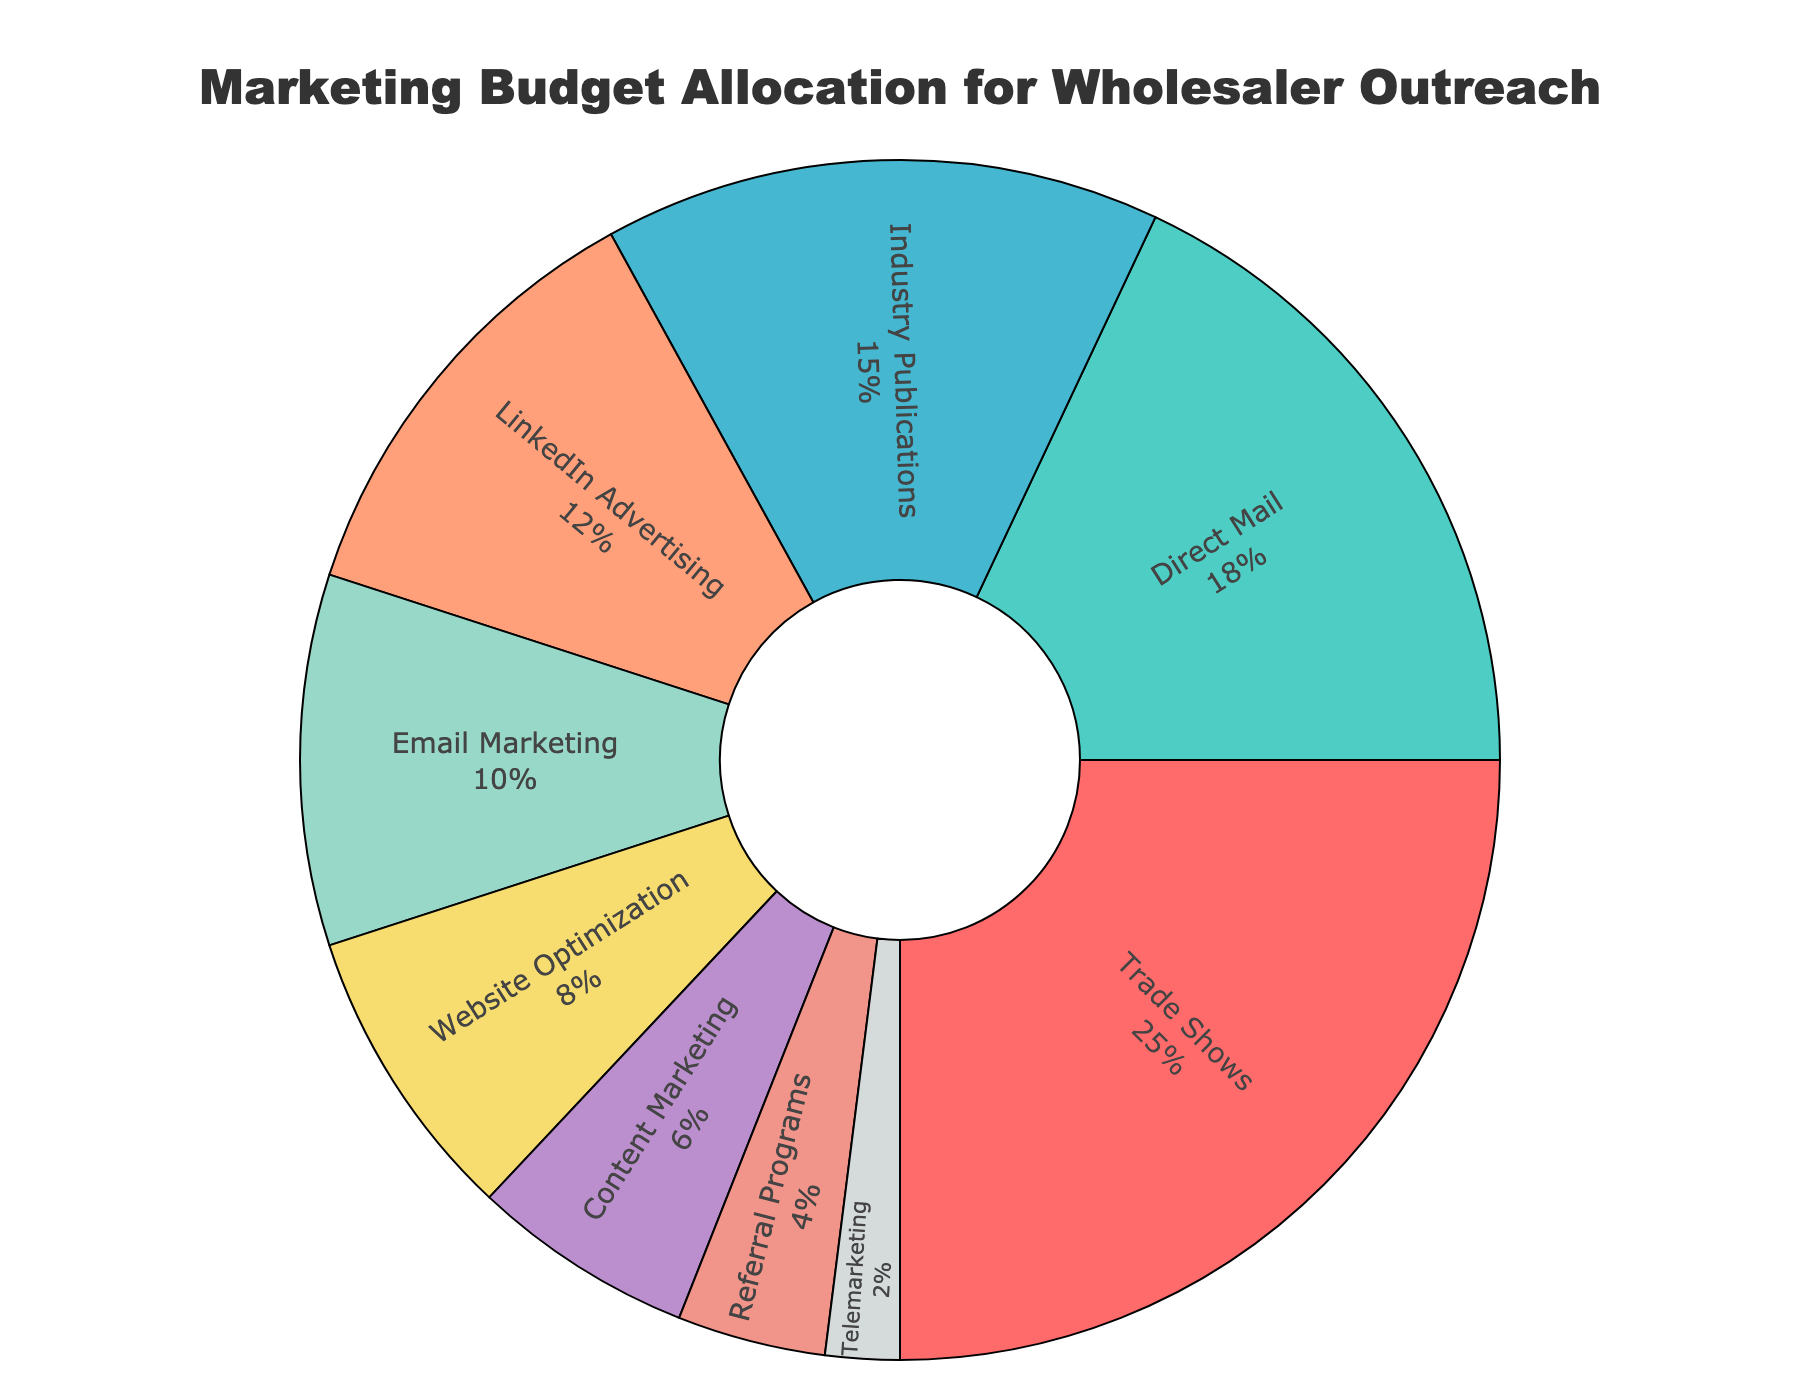Which channel has the highest marketing budget allocation? The channel with the highest marketing budget allocation is shown as the largest slice in the pie chart.
Answer: Trade Shows What is the combined budget allocation for LinkedIn Advertising and Email Marketing? Add the percentages for LinkedIn Advertising (12%) and Email Marketing (10%) together. 12 + 10 = 22%
Answer: 22% Which channels have a smaller budget allocation than Trade Shows? Identify the slices smaller than Trade Shows (25%). Trade Shows has the largest slice, so compare sizes visually. All channels other than Trade Shows have a smaller allocation.
Answer: Direct Mail, Industry Publications, LinkedIn Advertising, Email Marketing, Website Optimization, Content Marketing, Referral Programs, Telemarketing What is the difference in budget allocation between Trade Shows and Email Marketing? Subtract the percentage of Email Marketing (10%) from the percentage of Trade Shows (25%). 25 - 10 = 15%
Answer: 15% What is the average budget allocation across all channels? Add all the percentages together and divide by the number of channels. (25 + 18 + 15 + 12 + 10 + 8 + 6 + 4 + 2) = 100. There are 9 channels, so 100 / 9 ≈ 11.1%
Answer: 11.1% Which channel has the lowest marketing budget allocation? The channel with the smallest slice in the pie chart represents the lowest marketing budget allocation.
Answer: Telemarketing How much more budget is allocated to Industry Publications compared to Referral Programs? Subtract the percentage of Referral Programs (4%) from Industry Publications (15%). 15 - 4 = 11%
Answer: 11% Which channel has a budget allocation equal to 10%? Identify the slice in the pie chart labeled 10%.
Answer: Email Marketing What is the total budget allocation for channels dedicated to digital marketing (LinkedIn Advertising, Email Marketing, Website Optimization, and Content Marketing)? Add the percentages for LinkedIn Advertising (12%), Email Marketing (10%), Website Optimization (8%), and Content Marketing (6%). 12 + 10 + 8 + 6 = 36%
Answer: 36% What percentage of the marketing budget is allocated to non-digital channels? Subtract the total percentage for digital channels (36%) from 100%. 100 - 36 = 64%
Answer: 64% 